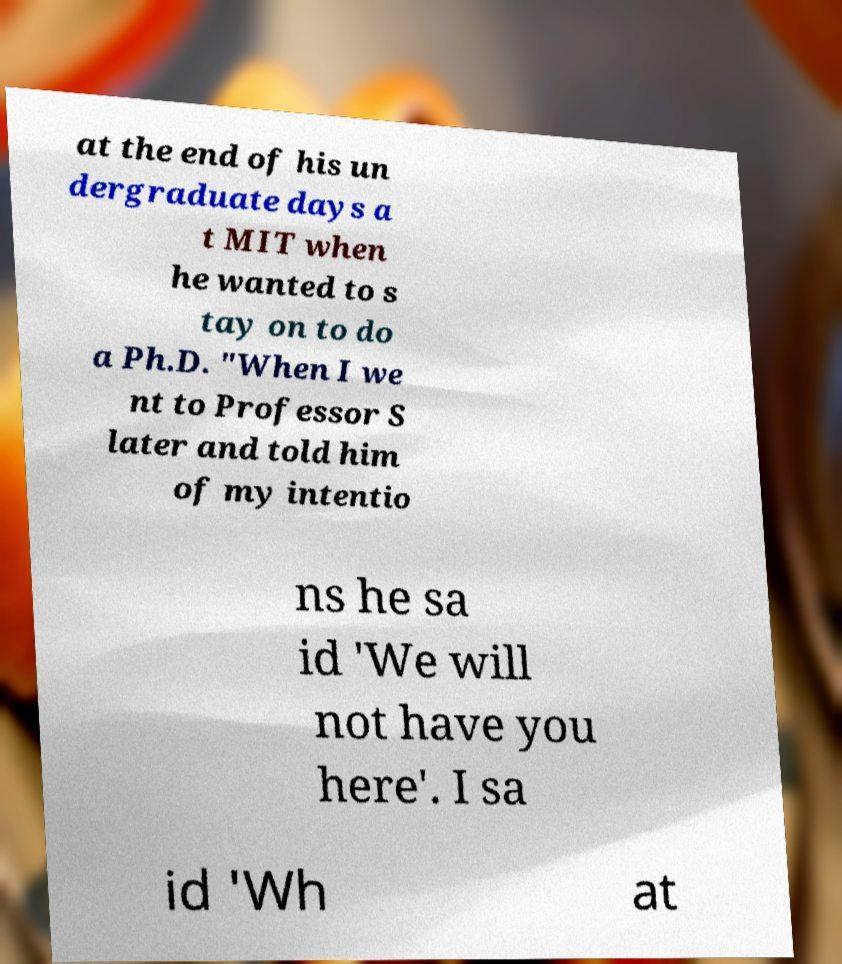Could you assist in decoding the text presented in this image and type it out clearly? at the end of his un dergraduate days a t MIT when he wanted to s tay on to do a Ph.D. "When I we nt to Professor S later and told him of my intentio ns he sa id 'We will not have you here'. I sa id 'Wh at 